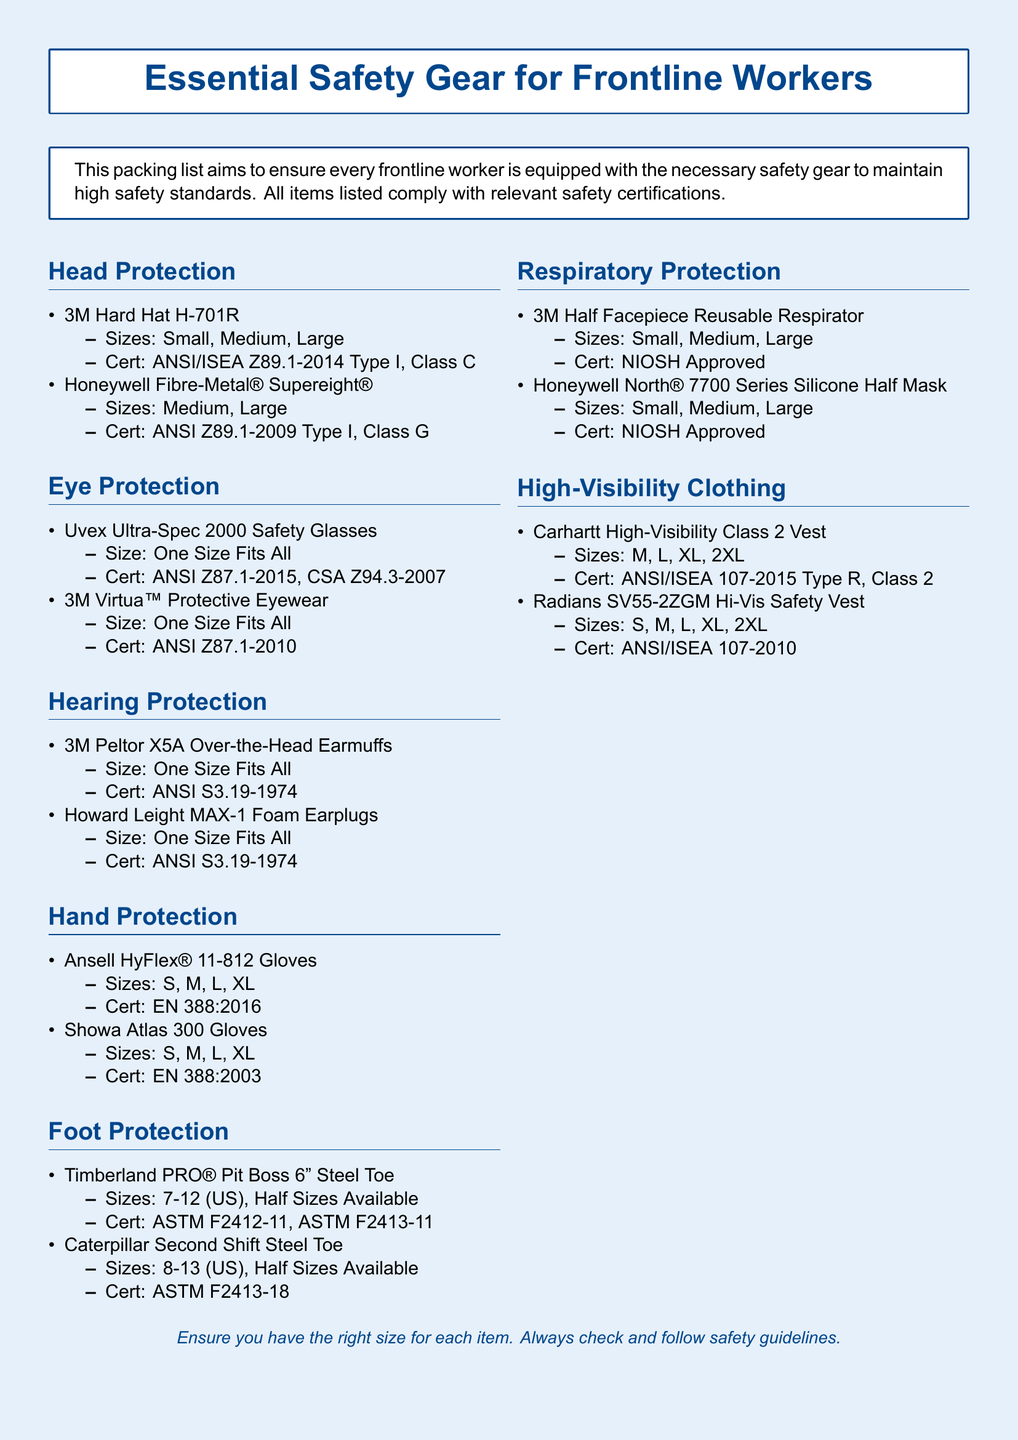What sizes are available for the 3M Hard Hat H-701R? The document lists the sizes available for the 3M Hard Hat H-701R as Small, Medium, and Large.
Answer: Small, Medium, Large Which certification does the Uvex Ultra-Spec 2000 Safety Glasses comply with? The document states the Uvex Ultra-Spec 2000 Safety Glasses comply with ANSI Z87.1-2015 and CSA Z94.3-2007 certifications.
Answer: ANSI Z87.1-2015, CSA Z94.3-2007 What is the size range for the Timberland PRO® Pit Boss 6" Steel Toe boots? The document indicates that the Timberland PRO® Pit Boss 6" Steel Toe boots are available in sizes 7-12 (US), with half sizes available.
Answer: 7-12 (US), Half Sizes Available How many different items are listed under Eye Protection? The document lists a total of two items under Eye Protection: Uvex Ultra-Spec 2000 Safety Glasses and 3M Virtua™ Protective Eyewear.
Answer: 2 What type of protection is the Howard Leight MAX-1? The document states that the Howard Leight MAX-1 is a Foam Earplug, which implies hearing protection.
Answer: Hearing Protection Which item offers hand protection and what is its certification? The document mentions Ansell HyFlex® 11-812 Gloves under Hand Protection, and it is certified to EN 388:2016.
Answer: Ansell HyFlex® 11-812 Gloves, EN 388:2016 What type of high-visibility clothing is listed in the document? The document lists the Carhartt High-Visibility Class 2 Vest and Radians SV55-2ZGM Hi-Vis Safety Vest as high-visibility clothing.
Answer: Carhartt High-Visibility Class 2 Vest, Radians SV55-2ZGM Hi-Vis Safety Vest What certifications do the respirators mentioned in the document have? The document states that both the 3M Half Facepiece Reusable Respirator and Honeywell North® 7700 Series Silicone Half Mask are NIOSH Approved.
Answer: NIOSH Approved 